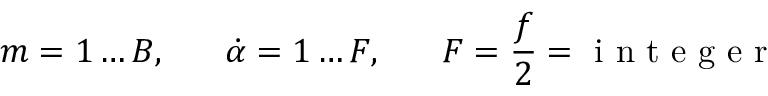Convert formula to latex. <formula><loc_0><loc_0><loc_500><loc_500>m = 1 \dots B , \, \dot { \alpha } = 1 \dots F , \, F = \frac { f } { 2 } = i n t e g e r</formula> 